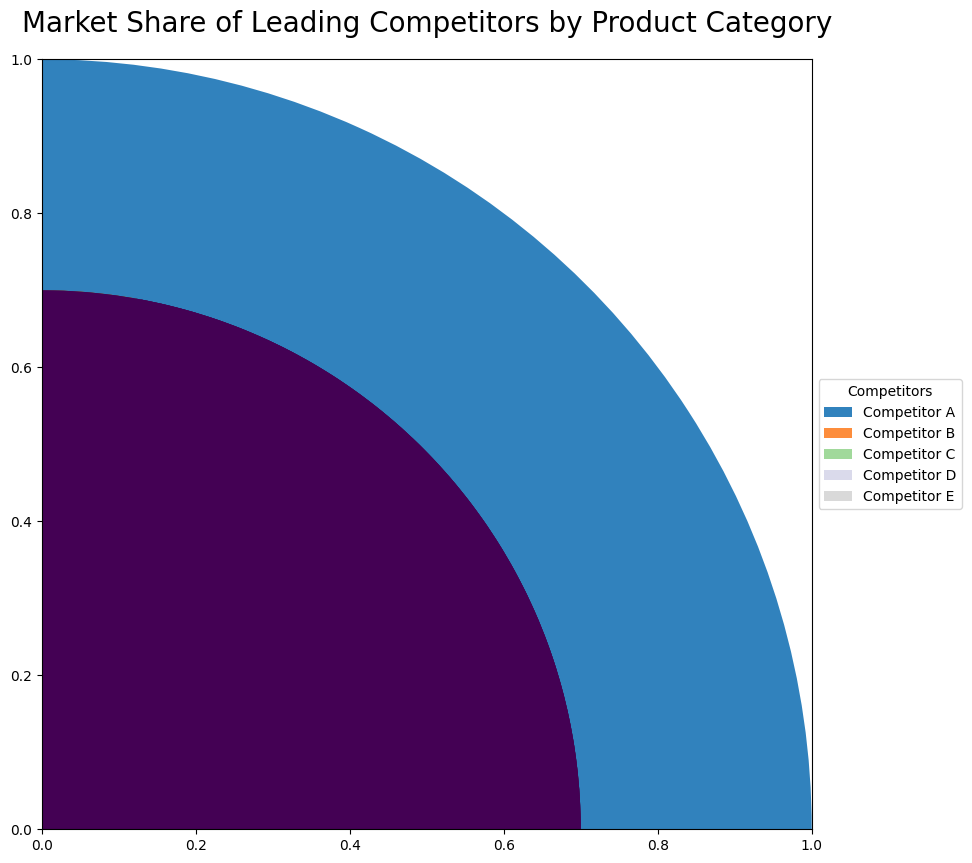Which competitor has the highest total market share? By looking at the outer ring of the chart, we identify the competitor with the largest wedge. Competitor A has the largest wedge in the outer ring, indicating the highest total market share.
Answer: Competitor A Which product category contributes the most to Competitor B's market share? For Competitor B, observe the inner segments of its outer wedge. The segment for Product Category 1 is the largest among Competitor B's inner segments.
Answer: Product Category 1 How does the market share of Product Category 2 for Competitor C compare to that of Competitor D? Locate the inner segments of both Competitor C and Competitor D in the ring chart. Product Category 2 for Competitor C has a larger segment than for Competitor D, implying a higher market share for Competitor C.
Answer: Competitor C has a higher market share in Product Category 2 than Competitor D What is the total market share for Product Category 1 across all competitors? Sum the market share values for Product Category 1 across all competitors (25 + 20 + 15 + 10 + 5). This totals up to 75.
Answer: 75 Which competitor has almost equal market share in Product Categories 1 and 2? By examining the inner segments for each competitor, we find that Competitor D shows similar-sized segments for Product Categories 1 and 2.
Answer: Competitor D Is Competitor E’s market share for Product Category 3 greater than Competitor D’s market share for the same category? Compare the inner segments for Product Category 3 of both Competitor E and Competitor D. Competitor E and Competitor D both have 2% for Product Category 3, making them equal.
Answer: No, they are equal If we combine the market share of Product Category 3 for Competitors C and E, does it surpass the market share of Product Category 2 for Competitor A? Add the market shares for Competitor C (3%) and Competitor E (2%) in Product Category 3, which equals 5%. This is less than Competitor A's 15% in Product Category 2.
Answer: No Which competitor has the smallest inner segment for Product Category 3? By looking at the inner segments for Product Category 3, we see Competitor D and Competitor E both have the smallest equal segments.
Answer: Competitor D and Competitor E 